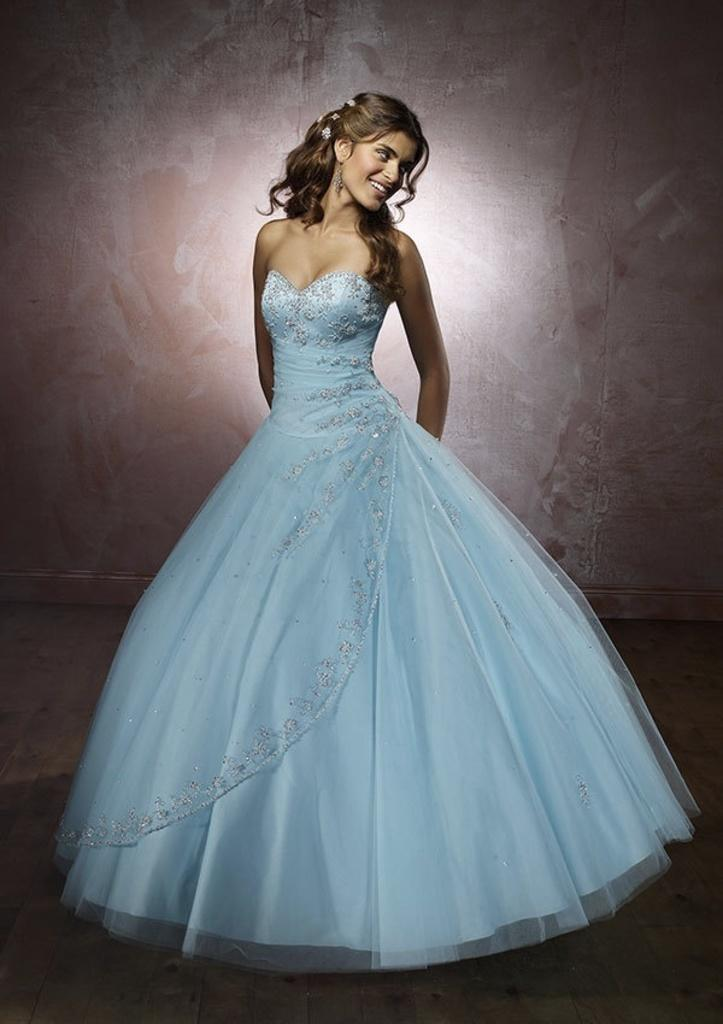Who is the main subject in the image? There is a girl in the image. What is the girl wearing? The girl is wearing a white frock. What is the girl's posture in the image? The girl is standing. What can be seen in the background of the image? There is a wall in the background of the image. What type of design does the visitor appreciate in the image? There is no visitor present in the image, and therefore no appreciation for any design can be observed. 